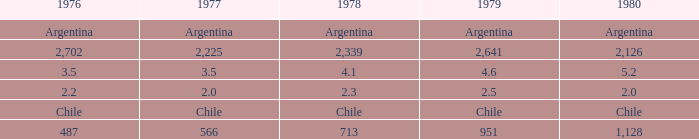What is 1980 when 1979 is 951? 1128.0. 